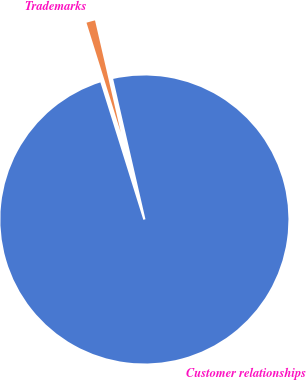Convert chart to OTSL. <chart><loc_0><loc_0><loc_500><loc_500><pie_chart><fcel>Customer relationships<fcel>Trademarks<nl><fcel>98.78%<fcel>1.22%<nl></chart> 